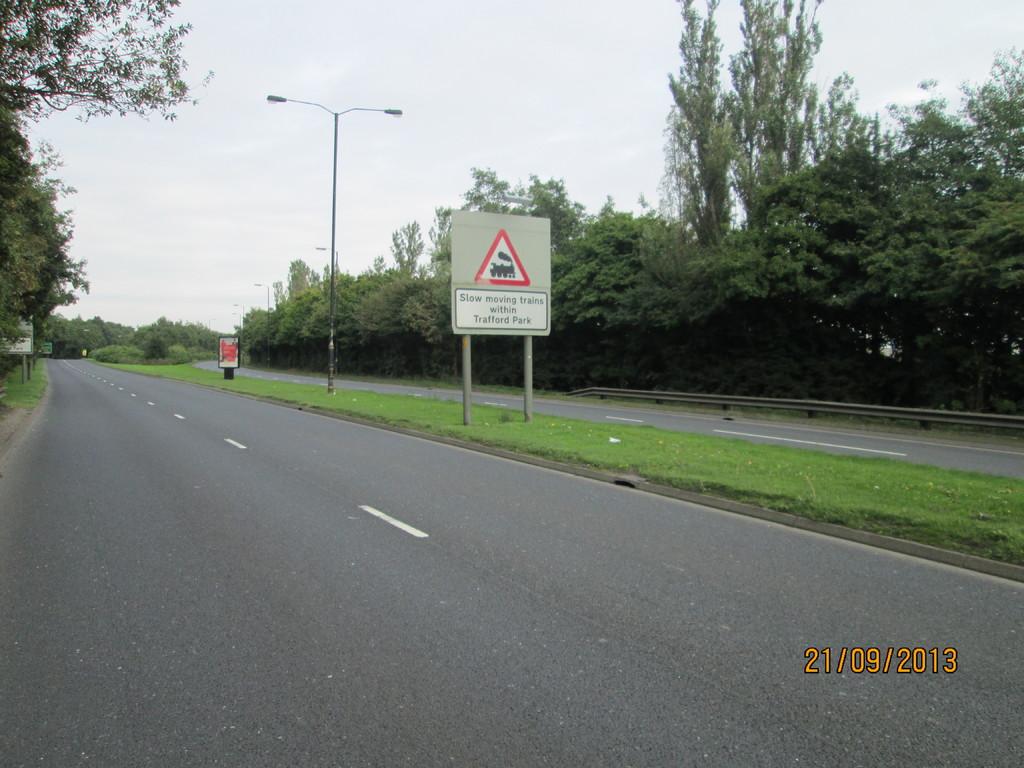What does the sign say ?
Your answer should be compact. Unanswerable. When was the picture taken?
Give a very brief answer. 21/09/2013. 